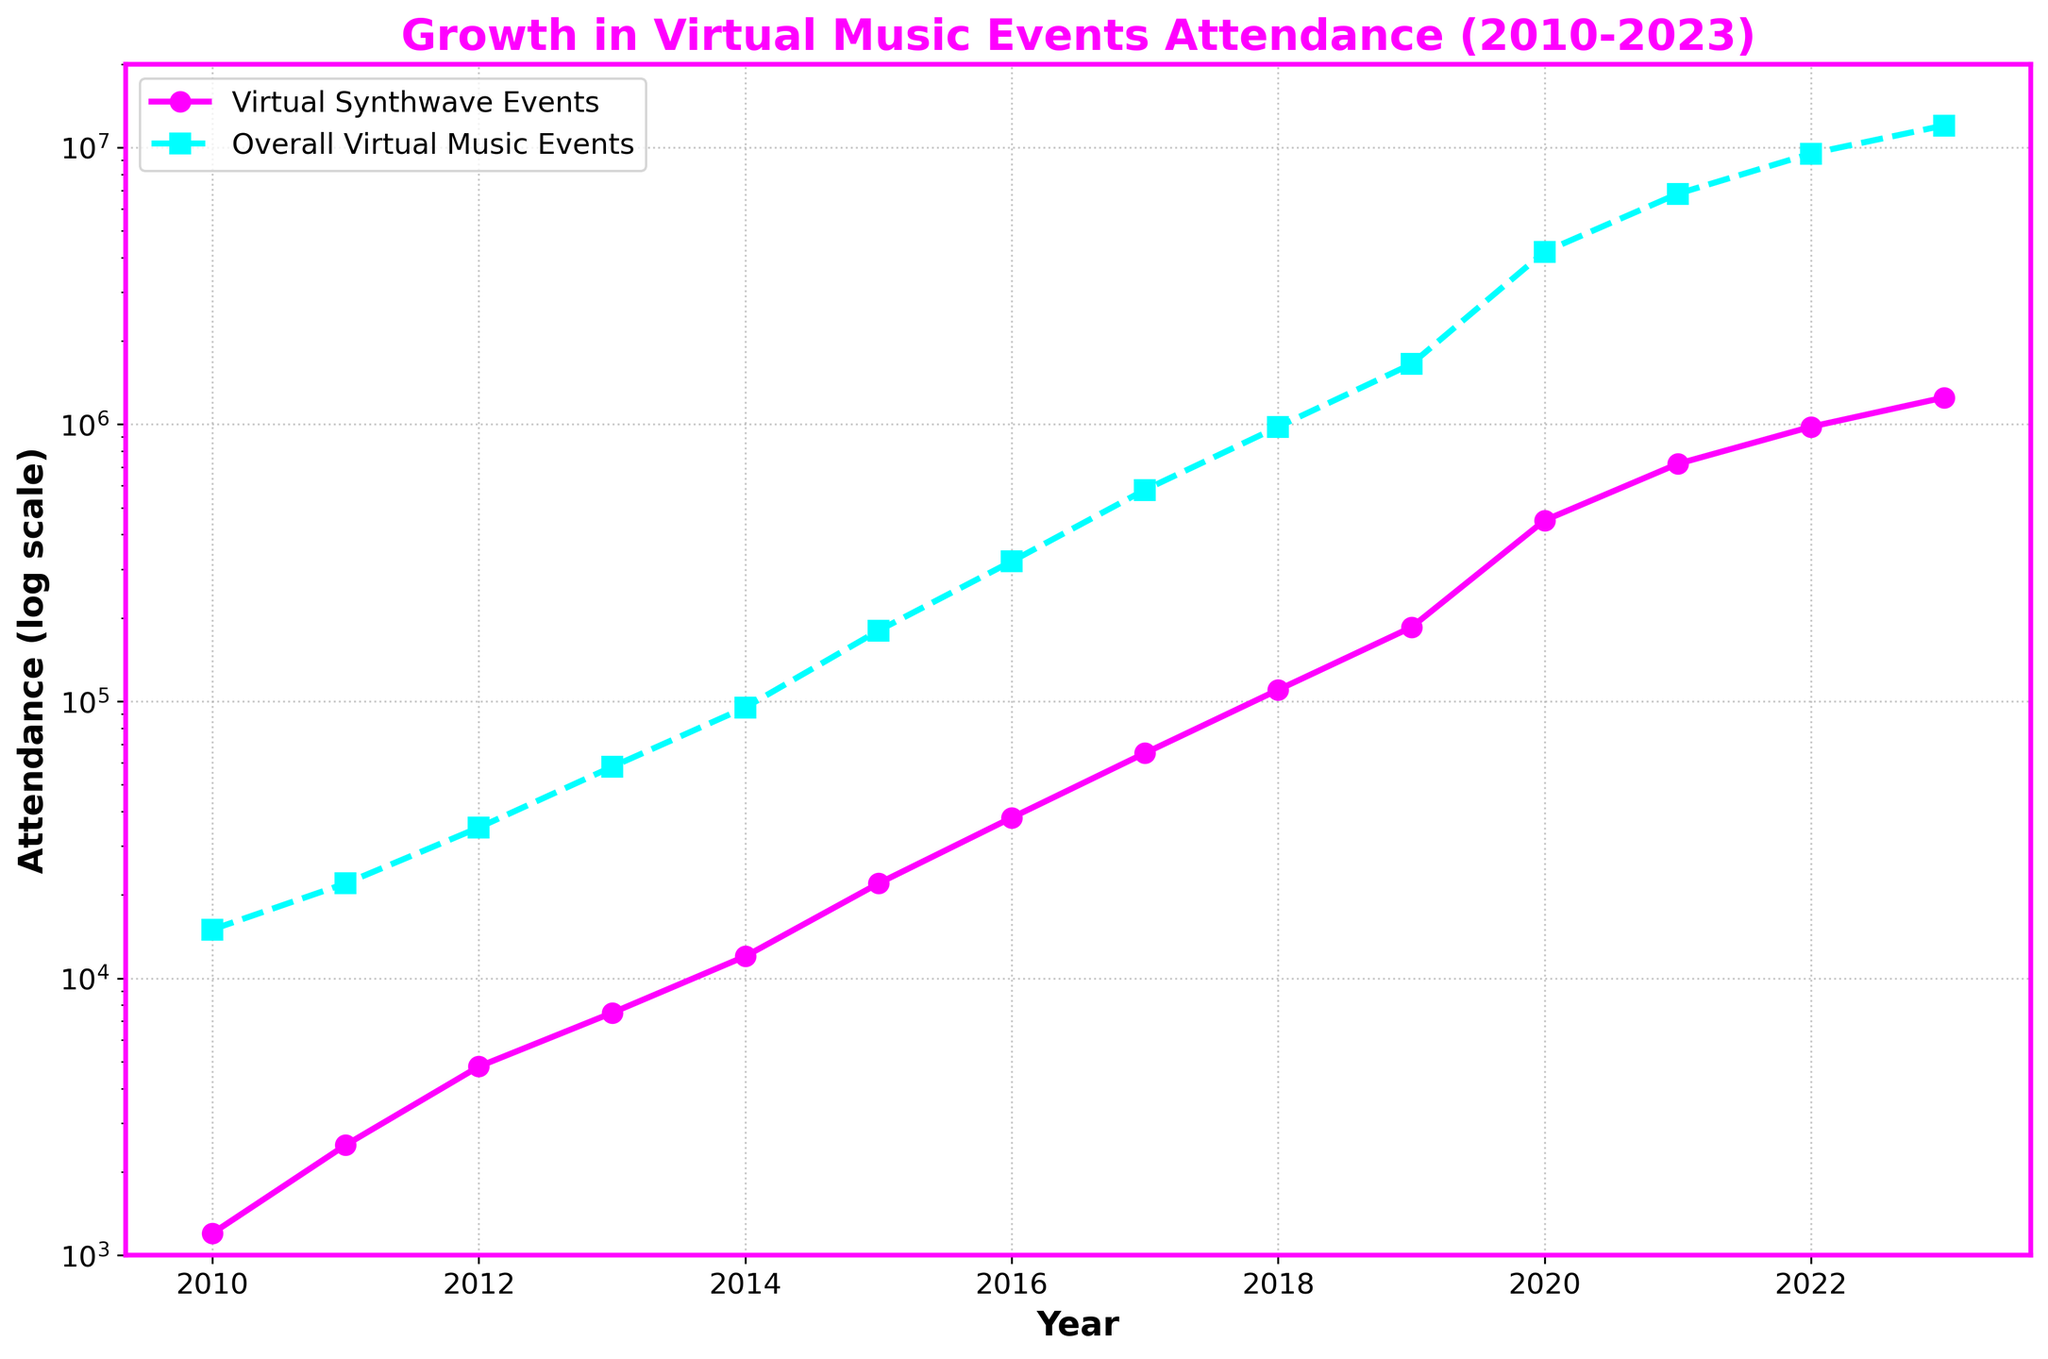Which year had the highest attendance for virtual synthwave events? Look at the pink line representing virtual synthwave events and find the year with the highest point. The highest point appears in 2023.
Answer: 2023 What is the difference in attendance between virtual synthwave events and overall virtual music events in 2020? Identify the attendance values for both virtual synthwave events and overall virtual music events in 2020 on the y-axis. Virtual synthwave events had 450,000 attendees and overall virtual music events had 4,200,000 attendees. Subtract the smaller value from the larger value (4,200,000 - 450,000).
Answer: 3,750,000 How did the attendance for overall virtual music events change from 2015 to 2017? Check the values on the y-axis for overall virtual music events in 2015 and 2017. In 2015, the attendance was 180,000, and in 2017, it was 580,000. Calculate the difference (580,000 - 180,000) and state whether it increased or decreased.
Answer: Increased by 400,000 Compare the growth rates of virtual synthwave events and overall virtual music events from 2010 to 2023. Which grew faster? Normalize the values and observe the slope of the lines from 2010 to 2023. The pink line (virtual synthwave events) and the blue line (overall virtual music events) both show significant growth, but the virtual synthwave events line seems steeper, indicating a faster relative growth rate.
Answer: Virtual synthwave events In which year did both the virtual synthwave events and overall virtual music events see the most significant jump in attendance? Observe the steepest vertical increases in the lines for both virtual synthwave events and overall virtual music events. The steepest rise for both occurs around 2020.
Answer: 2020 What is the average attendance for virtual synthwave events between 2010 and 2015? Sum the attendance figures from 2010 to 2015 for virtual synthwave events (1200 + 2500 + 4800 + 7500 + 12000 + 22000) and divide by the number of years (6). The sum is 50,000, and the average is 50,000 / 6.
Answer: 8333 By how much did the attendance for virtual synthwave events increase from 2019 to 2021? Identify the attendance values for virtual synthwave events in 2019 and 2021. In 2019, the attendance was 185,000, and in 2021, it was 720,000. Calculate the difference (720,000 - 185,000).
Answer: 535,000 Which segment (virtual synthwave events or overall virtual music events) had more stable growth from 2010 to 2019 based on the chart? Look at the smoothness and consistency of the lines from 2010 to 2019. The blue line for overall virtual music events shows smoother and less volatile incremental growth compared to the pink line for virtual synthwave events which has more fluctuations.
Answer: Overall virtual music events Identify one year where virtual synthwave events had a significant increase in attendance not mirrored by overall virtual music events? Compare both lines year by year for noticeable sharp increases in the pink line that are not similarly observed in the blue line. The year 2016 shows a marked increase for virtual synthwave events not equally mirrored by overall virtual music events.
Answer: 2016 